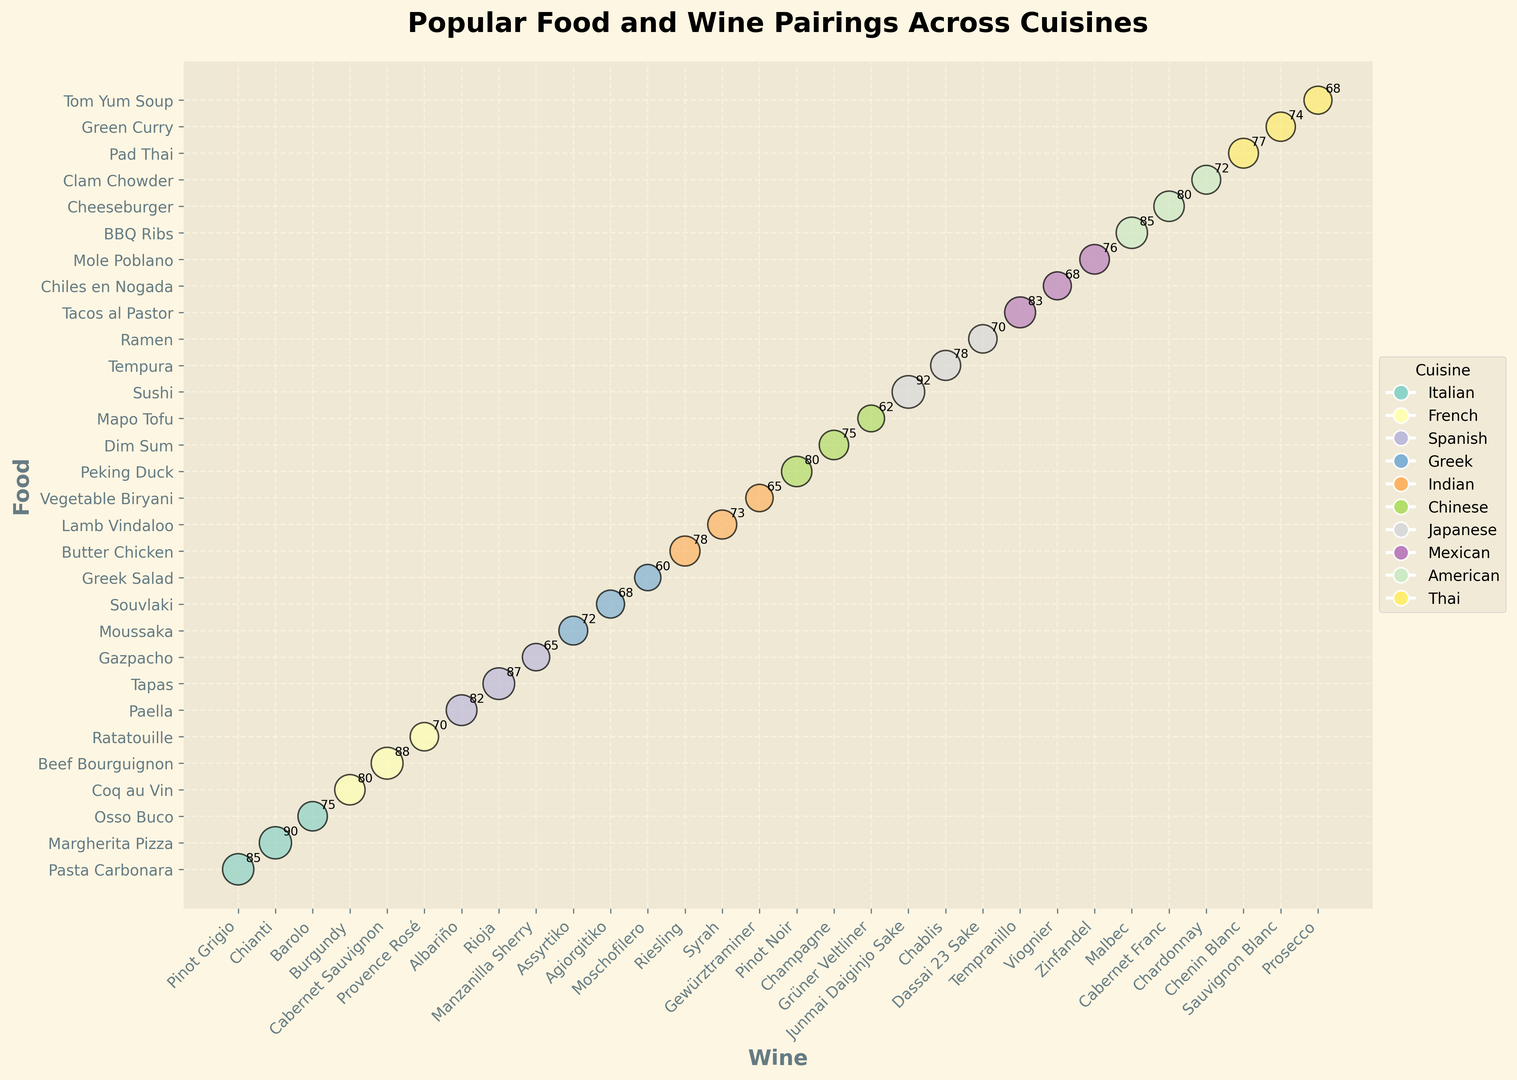Which cuisine has the highest popularity paired with wine? By looking at the bubbles with the largest size, identify the one related to the highest popularity score. The largest bubble corresponds to Japanese cuisine paired with Junmai Daiginjo Sake for Sushi, with a popularity score of 92.
Answer: Japanese Which cuisine has multiple pairings with wine? Observe cuisines that have more than one bubble associated with different food and wine pairings. Italian, French, Spanish, Greek, Indian, Chinese, Japanese, Mexican, American, and Thai cuisines all have multiple pairings.
Answer: Italian, French, Spanish, Greek, Indian, Chinese, Japanese, Mexican, American, Thai Which wine is paired with the least popular food in the Greek cuisine? Look for the smallest bubble within the Greek cuisine and check the Wine label associated with it. The smallest bubble in Greek cuisine corresponds to Greek Salad paired with Moschofilero, with a popularity score of 60.
Answer: Moschofilero How does the popularity of BBQ Ribs paired with Malbec compare to Paella paired with Albariño? Locate the bubbles representing BBQ Ribs with Malbec and Paella with Albariño and compare their sizes. BBQ Ribs paired with Malbec has a popularity of 85, whereas Paella paired with Albariño has a popularity of 82, so BBQ Ribs with Malbec is more popular.
Answer: BBQ Ribs with Malbec is more popular What's the average popularity of the Japanese pairings? Find all bubbles related to Japanese cuisine and calculate their average popularity score. The scores for Japanese are Sushi (92), Tempura (78), and Ramen (70). The average is (92 + 78 + 70) / 3 = 80.
Answer: 80 Which cuisine has the most pairings? Count the number of bubbles for each cuisine and determine which one has the highest count. Italian cuisine has 3 pairings (Pasta Carbonara, Margherita Pizza, and Osso Buco).
Answer: Italian Which wine pairs with Butter Chicken in Indian cuisine, and how popular is it? Find the bubble for Butter Chicken under Indian cuisine and note the wine and its popularity score. Butter Chicken is paired with Riesling, with a popularity of 78.
Answer: Riesling and 78 